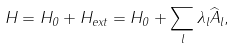<formula> <loc_0><loc_0><loc_500><loc_500>H = H _ { 0 } + H _ { e x t } = H _ { 0 } + \sum _ { l } \lambda _ { l } \widehat { A } _ { l } ,</formula> 